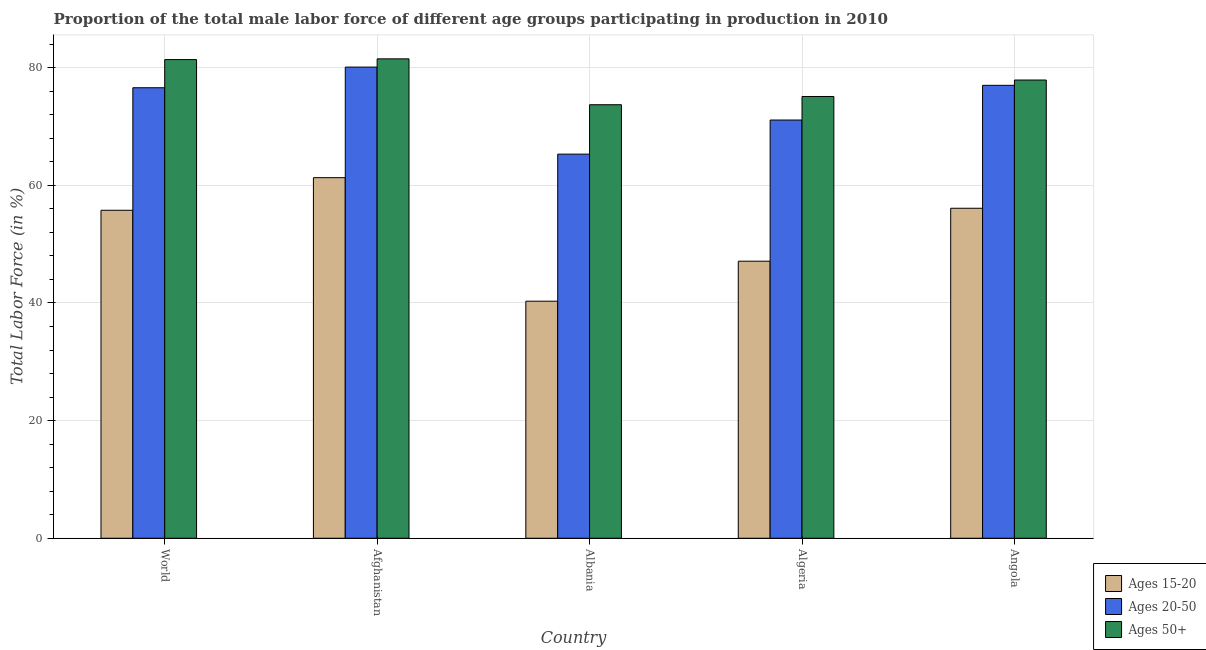How many groups of bars are there?
Offer a terse response. 5. Are the number of bars per tick equal to the number of legend labels?
Keep it short and to the point. Yes. Are the number of bars on each tick of the X-axis equal?
Your answer should be very brief. Yes. How many bars are there on the 2nd tick from the left?
Provide a succinct answer. 3. What is the label of the 2nd group of bars from the left?
Provide a short and direct response. Afghanistan. What is the percentage of male labor force within the age group 20-50 in Algeria?
Offer a very short reply. 71.1. Across all countries, what is the maximum percentage of male labor force within the age group 15-20?
Your answer should be very brief. 61.3. Across all countries, what is the minimum percentage of male labor force above age 50?
Give a very brief answer. 73.7. In which country was the percentage of male labor force above age 50 maximum?
Provide a short and direct response. Afghanistan. In which country was the percentage of male labor force within the age group 15-20 minimum?
Ensure brevity in your answer.  Albania. What is the total percentage of male labor force within the age group 15-20 in the graph?
Offer a terse response. 260.56. What is the difference between the percentage of male labor force above age 50 in Afghanistan and that in Algeria?
Your answer should be compact. 6.4. What is the difference between the percentage of male labor force within the age group 20-50 in Angola and the percentage of male labor force within the age group 15-20 in World?
Make the answer very short. 21.24. What is the average percentage of male labor force within the age group 20-50 per country?
Your answer should be compact. 74.02. What is the difference between the percentage of male labor force within the age group 15-20 and percentage of male labor force within the age group 20-50 in Afghanistan?
Make the answer very short. -18.8. In how many countries, is the percentage of male labor force within the age group 20-50 greater than 8 %?
Provide a succinct answer. 5. What is the ratio of the percentage of male labor force above age 50 in Albania to that in Angola?
Provide a succinct answer. 0.95. Is the difference between the percentage of male labor force within the age group 15-20 in Albania and Algeria greater than the difference between the percentage of male labor force within the age group 20-50 in Albania and Algeria?
Your answer should be compact. No. What is the difference between the highest and the second highest percentage of male labor force within the age group 20-50?
Give a very brief answer. 3.1. In how many countries, is the percentage of male labor force within the age group 15-20 greater than the average percentage of male labor force within the age group 15-20 taken over all countries?
Make the answer very short. 3. Is the sum of the percentage of male labor force within the age group 20-50 in Algeria and Angola greater than the maximum percentage of male labor force above age 50 across all countries?
Your response must be concise. Yes. What does the 3rd bar from the left in Algeria represents?
Provide a short and direct response. Ages 50+. What does the 3rd bar from the right in Algeria represents?
Give a very brief answer. Ages 15-20. Are all the bars in the graph horizontal?
Keep it short and to the point. No. Are the values on the major ticks of Y-axis written in scientific E-notation?
Keep it short and to the point. No. Does the graph contain any zero values?
Offer a terse response. No. Where does the legend appear in the graph?
Give a very brief answer. Bottom right. How many legend labels are there?
Provide a succinct answer. 3. What is the title of the graph?
Your response must be concise. Proportion of the total male labor force of different age groups participating in production in 2010. What is the label or title of the Y-axis?
Give a very brief answer. Total Labor Force (in %). What is the Total Labor Force (in %) in Ages 15-20 in World?
Your answer should be compact. 55.76. What is the Total Labor Force (in %) of Ages 20-50 in World?
Offer a very short reply. 76.59. What is the Total Labor Force (in %) of Ages 50+ in World?
Offer a terse response. 81.37. What is the Total Labor Force (in %) in Ages 15-20 in Afghanistan?
Give a very brief answer. 61.3. What is the Total Labor Force (in %) in Ages 20-50 in Afghanistan?
Give a very brief answer. 80.1. What is the Total Labor Force (in %) of Ages 50+ in Afghanistan?
Keep it short and to the point. 81.5. What is the Total Labor Force (in %) of Ages 15-20 in Albania?
Give a very brief answer. 40.3. What is the Total Labor Force (in %) in Ages 20-50 in Albania?
Your answer should be very brief. 65.3. What is the Total Labor Force (in %) in Ages 50+ in Albania?
Provide a short and direct response. 73.7. What is the Total Labor Force (in %) of Ages 15-20 in Algeria?
Your response must be concise. 47.1. What is the Total Labor Force (in %) of Ages 20-50 in Algeria?
Your response must be concise. 71.1. What is the Total Labor Force (in %) in Ages 50+ in Algeria?
Keep it short and to the point. 75.1. What is the Total Labor Force (in %) of Ages 15-20 in Angola?
Keep it short and to the point. 56.1. What is the Total Labor Force (in %) of Ages 50+ in Angola?
Offer a very short reply. 77.9. Across all countries, what is the maximum Total Labor Force (in %) of Ages 15-20?
Your answer should be very brief. 61.3. Across all countries, what is the maximum Total Labor Force (in %) in Ages 20-50?
Offer a terse response. 80.1. Across all countries, what is the maximum Total Labor Force (in %) in Ages 50+?
Offer a terse response. 81.5. Across all countries, what is the minimum Total Labor Force (in %) in Ages 15-20?
Offer a very short reply. 40.3. Across all countries, what is the minimum Total Labor Force (in %) in Ages 20-50?
Make the answer very short. 65.3. Across all countries, what is the minimum Total Labor Force (in %) of Ages 50+?
Give a very brief answer. 73.7. What is the total Total Labor Force (in %) of Ages 15-20 in the graph?
Keep it short and to the point. 260.56. What is the total Total Labor Force (in %) of Ages 20-50 in the graph?
Give a very brief answer. 370.09. What is the total Total Labor Force (in %) of Ages 50+ in the graph?
Offer a very short reply. 389.57. What is the difference between the Total Labor Force (in %) in Ages 15-20 in World and that in Afghanistan?
Your answer should be very brief. -5.54. What is the difference between the Total Labor Force (in %) in Ages 20-50 in World and that in Afghanistan?
Your response must be concise. -3.51. What is the difference between the Total Labor Force (in %) in Ages 50+ in World and that in Afghanistan?
Your answer should be very brief. -0.13. What is the difference between the Total Labor Force (in %) in Ages 15-20 in World and that in Albania?
Ensure brevity in your answer.  15.46. What is the difference between the Total Labor Force (in %) in Ages 20-50 in World and that in Albania?
Your response must be concise. 11.29. What is the difference between the Total Labor Force (in %) in Ages 50+ in World and that in Albania?
Your answer should be very brief. 7.67. What is the difference between the Total Labor Force (in %) in Ages 15-20 in World and that in Algeria?
Your answer should be very brief. 8.66. What is the difference between the Total Labor Force (in %) of Ages 20-50 in World and that in Algeria?
Offer a very short reply. 5.49. What is the difference between the Total Labor Force (in %) in Ages 50+ in World and that in Algeria?
Provide a succinct answer. 6.27. What is the difference between the Total Labor Force (in %) of Ages 15-20 in World and that in Angola?
Give a very brief answer. -0.34. What is the difference between the Total Labor Force (in %) of Ages 20-50 in World and that in Angola?
Ensure brevity in your answer.  -0.41. What is the difference between the Total Labor Force (in %) of Ages 50+ in World and that in Angola?
Your response must be concise. 3.47. What is the difference between the Total Labor Force (in %) in Ages 15-20 in Afghanistan and that in Albania?
Your answer should be very brief. 21. What is the difference between the Total Labor Force (in %) of Ages 20-50 in Afghanistan and that in Albania?
Your response must be concise. 14.8. What is the difference between the Total Labor Force (in %) of Ages 50+ in Afghanistan and that in Albania?
Your answer should be compact. 7.8. What is the difference between the Total Labor Force (in %) of Ages 15-20 in Afghanistan and that in Algeria?
Offer a terse response. 14.2. What is the difference between the Total Labor Force (in %) of Ages 50+ in Afghanistan and that in Algeria?
Provide a succinct answer. 6.4. What is the difference between the Total Labor Force (in %) of Ages 15-20 in Afghanistan and that in Angola?
Make the answer very short. 5.2. What is the difference between the Total Labor Force (in %) of Ages 15-20 in Albania and that in Algeria?
Provide a short and direct response. -6.8. What is the difference between the Total Labor Force (in %) of Ages 50+ in Albania and that in Algeria?
Provide a succinct answer. -1.4. What is the difference between the Total Labor Force (in %) in Ages 15-20 in Albania and that in Angola?
Ensure brevity in your answer.  -15.8. What is the difference between the Total Labor Force (in %) of Ages 20-50 in Albania and that in Angola?
Your answer should be very brief. -11.7. What is the difference between the Total Labor Force (in %) of Ages 15-20 in Algeria and that in Angola?
Offer a terse response. -9. What is the difference between the Total Labor Force (in %) in Ages 20-50 in Algeria and that in Angola?
Your answer should be very brief. -5.9. What is the difference between the Total Labor Force (in %) of Ages 15-20 in World and the Total Labor Force (in %) of Ages 20-50 in Afghanistan?
Give a very brief answer. -24.34. What is the difference between the Total Labor Force (in %) of Ages 15-20 in World and the Total Labor Force (in %) of Ages 50+ in Afghanistan?
Keep it short and to the point. -25.74. What is the difference between the Total Labor Force (in %) of Ages 20-50 in World and the Total Labor Force (in %) of Ages 50+ in Afghanistan?
Provide a short and direct response. -4.91. What is the difference between the Total Labor Force (in %) in Ages 15-20 in World and the Total Labor Force (in %) in Ages 20-50 in Albania?
Your answer should be compact. -9.54. What is the difference between the Total Labor Force (in %) in Ages 15-20 in World and the Total Labor Force (in %) in Ages 50+ in Albania?
Your response must be concise. -17.94. What is the difference between the Total Labor Force (in %) in Ages 20-50 in World and the Total Labor Force (in %) in Ages 50+ in Albania?
Your response must be concise. 2.89. What is the difference between the Total Labor Force (in %) of Ages 15-20 in World and the Total Labor Force (in %) of Ages 20-50 in Algeria?
Provide a short and direct response. -15.34. What is the difference between the Total Labor Force (in %) in Ages 15-20 in World and the Total Labor Force (in %) in Ages 50+ in Algeria?
Your answer should be very brief. -19.34. What is the difference between the Total Labor Force (in %) in Ages 20-50 in World and the Total Labor Force (in %) in Ages 50+ in Algeria?
Keep it short and to the point. 1.49. What is the difference between the Total Labor Force (in %) in Ages 15-20 in World and the Total Labor Force (in %) in Ages 20-50 in Angola?
Your answer should be compact. -21.24. What is the difference between the Total Labor Force (in %) in Ages 15-20 in World and the Total Labor Force (in %) in Ages 50+ in Angola?
Ensure brevity in your answer.  -22.14. What is the difference between the Total Labor Force (in %) in Ages 20-50 in World and the Total Labor Force (in %) in Ages 50+ in Angola?
Your response must be concise. -1.31. What is the difference between the Total Labor Force (in %) of Ages 15-20 in Afghanistan and the Total Labor Force (in %) of Ages 20-50 in Albania?
Provide a short and direct response. -4. What is the difference between the Total Labor Force (in %) in Ages 15-20 in Afghanistan and the Total Labor Force (in %) in Ages 50+ in Albania?
Offer a terse response. -12.4. What is the difference between the Total Labor Force (in %) of Ages 20-50 in Afghanistan and the Total Labor Force (in %) of Ages 50+ in Albania?
Give a very brief answer. 6.4. What is the difference between the Total Labor Force (in %) in Ages 20-50 in Afghanistan and the Total Labor Force (in %) in Ages 50+ in Algeria?
Offer a very short reply. 5. What is the difference between the Total Labor Force (in %) of Ages 15-20 in Afghanistan and the Total Labor Force (in %) of Ages 20-50 in Angola?
Make the answer very short. -15.7. What is the difference between the Total Labor Force (in %) of Ages 15-20 in Afghanistan and the Total Labor Force (in %) of Ages 50+ in Angola?
Provide a succinct answer. -16.6. What is the difference between the Total Labor Force (in %) in Ages 15-20 in Albania and the Total Labor Force (in %) in Ages 20-50 in Algeria?
Ensure brevity in your answer.  -30.8. What is the difference between the Total Labor Force (in %) of Ages 15-20 in Albania and the Total Labor Force (in %) of Ages 50+ in Algeria?
Keep it short and to the point. -34.8. What is the difference between the Total Labor Force (in %) of Ages 20-50 in Albania and the Total Labor Force (in %) of Ages 50+ in Algeria?
Give a very brief answer. -9.8. What is the difference between the Total Labor Force (in %) in Ages 15-20 in Albania and the Total Labor Force (in %) in Ages 20-50 in Angola?
Your answer should be compact. -36.7. What is the difference between the Total Labor Force (in %) of Ages 15-20 in Albania and the Total Labor Force (in %) of Ages 50+ in Angola?
Offer a very short reply. -37.6. What is the difference between the Total Labor Force (in %) in Ages 15-20 in Algeria and the Total Labor Force (in %) in Ages 20-50 in Angola?
Keep it short and to the point. -29.9. What is the difference between the Total Labor Force (in %) of Ages 15-20 in Algeria and the Total Labor Force (in %) of Ages 50+ in Angola?
Offer a terse response. -30.8. What is the average Total Labor Force (in %) in Ages 15-20 per country?
Your answer should be very brief. 52.11. What is the average Total Labor Force (in %) in Ages 20-50 per country?
Ensure brevity in your answer.  74.02. What is the average Total Labor Force (in %) of Ages 50+ per country?
Provide a short and direct response. 77.91. What is the difference between the Total Labor Force (in %) of Ages 15-20 and Total Labor Force (in %) of Ages 20-50 in World?
Keep it short and to the point. -20.83. What is the difference between the Total Labor Force (in %) of Ages 15-20 and Total Labor Force (in %) of Ages 50+ in World?
Make the answer very short. -25.62. What is the difference between the Total Labor Force (in %) of Ages 20-50 and Total Labor Force (in %) of Ages 50+ in World?
Provide a short and direct response. -4.79. What is the difference between the Total Labor Force (in %) in Ages 15-20 and Total Labor Force (in %) in Ages 20-50 in Afghanistan?
Your response must be concise. -18.8. What is the difference between the Total Labor Force (in %) of Ages 15-20 and Total Labor Force (in %) of Ages 50+ in Afghanistan?
Your answer should be compact. -20.2. What is the difference between the Total Labor Force (in %) of Ages 20-50 and Total Labor Force (in %) of Ages 50+ in Afghanistan?
Provide a succinct answer. -1.4. What is the difference between the Total Labor Force (in %) of Ages 15-20 and Total Labor Force (in %) of Ages 20-50 in Albania?
Keep it short and to the point. -25. What is the difference between the Total Labor Force (in %) of Ages 15-20 and Total Labor Force (in %) of Ages 50+ in Albania?
Your answer should be very brief. -33.4. What is the difference between the Total Labor Force (in %) of Ages 20-50 and Total Labor Force (in %) of Ages 50+ in Albania?
Give a very brief answer. -8.4. What is the difference between the Total Labor Force (in %) of Ages 15-20 and Total Labor Force (in %) of Ages 50+ in Algeria?
Make the answer very short. -28. What is the difference between the Total Labor Force (in %) of Ages 15-20 and Total Labor Force (in %) of Ages 20-50 in Angola?
Provide a succinct answer. -20.9. What is the difference between the Total Labor Force (in %) of Ages 15-20 and Total Labor Force (in %) of Ages 50+ in Angola?
Your response must be concise. -21.8. What is the ratio of the Total Labor Force (in %) of Ages 15-20 in World to that in Afghanistan?
Provide a short and direct response. 0.91. What is the ratio of the Total Labor Force (in %) in Ages 20-50 in World to that in Afghanistan?
Provide a short and direct response. 0.96. What is the ratio of the Total Labor Force (in %) in Ages 50+ in World to that in Afghanistan?
Your response must be concise. 1. What is the ratio of the Total Labor Force (in %) of Ages 15-20 in World to that in Albania?
Your answer should be compact. 1.38. What is the ratio of the Total Labor Force (in %) in Ages 20-50 in World to that in Albania?
Keep it short and to the point. 1.17. What is the ratio of the Total Labor Force (in %) in Ages 50+ in World to that in Albania?
Your response must be concise. 1.1. What is the ratio of the Total Labor Force (in %) in Ages 15-20 in World to that in Algeria?
Offer a terse response. 1.18. What is the ratio of the Total Labor Force (in %) in Ages 20-50 in World to that in Algeria?
Provide a short and direct response. 1.08. What is the ratio of the Total Labor Force (in %) of Ages 50+ in World to that in Algeria?
Provide a short and direct response. 1.08. What is the ratio of the Total Labor Force (in %) of Ages 15-20 in World to that in Angola?
Make the answer very short. 0.99. What is the ratio of the Total Labor Force (in %) in Ages 20-50 in World to that in Angola?
Provide a succinct answer. 0.99. What is the ratio of the Total Labor Force (in %) in Ages 50+ in World to that in Angola?
Provide a succinct answer. 1.04. What is the ratio of the Total Labor Force (in %) of Ages 15-20 in Afghanistan to that in Albania?
Your answer should be very brief. 1.52. What is the ratio of the Total Labor Force (in %) of Ages 20-50 in Afghanistan to that in Albania?
Provide a succinct answer. 1.23. What is the ratio of the Total Labor Force (in %) of Ages 50+ in Afghanistan to that in Albania?
Provide a succinct answer. 1.11. What is the ratio of the Total Labor Force (in %) of Ages 15-20 in Afghanistan to that in Algeria?
Provide a short and direct response. 1.3. What is the ratio of the Total Labor Force (in %) of Ages 20-50 in Afghanistan to that in Algeria?
Make the answer very short. 1.13. What is the ratio of the Total Labor Force (in %) in Ages 50+ in Afghanistan to that in Algeria?
Your answer should be very brief. 1.09. What is the ratio of the Total Labor Force (in %) of Ages 15-20 in Afghanistan to that in Angola?
Your answer should be very brief. 1.09. What is the ratio of the Total Labor Force (in %) of Ages 20-50 in Afghanistan to that in Angola?
Your answer should be compact. 1.04. What is the ratio of the Total Labor Force (in %) in Ages 50+ in Afghanistan to that in Angola?
Your response must be concise. 1.05. What is the ratio of the Total Labor Force (in %) in Ages 15-20 in Albania to that in Algeria?
Offer a terse response. 0.86. What is the ratio of the Total Labor Force (in %) in Ages 20-50 in Albania to that in Algeria?
Ensure brevity in your answer.  0.92. What is the ratio of the Total Labor Force (in %) of Ages 50+ in Albania to that in Algeria?
Ensure brevity in your answer.  0.98. What is the ratio of the Total Labor Force (in %) in Ages 15-20 in Albania to that in Angola?
Offer a very short reply. 0.72. What is the ratio of the Total Labor Force (in %) of Ages 20-50 in Albania to that in Angola?
Your answer should be compact. 0.85. What is the ratio of the Total Labor Force (in %) of Ages 50+ in Albania to that in Angola?
Provide a short and direct response. 0.95. What is the ratio of the Total Labor Force (in %) in Ages 15-20 in Algeria to that in Angola?
Your response must be concise. 0.84. What is the ratio of the Total Labor Force (in %) of Ages 20-50 in Algeria to that in Angola?
Offer a terse response. 0.92. What is the ratio of the Total Labor Force (in %) of Ages 50+ in Algeria to that in Angola?
Provide a succinct answer. 0.96. What is the difference between the highest and the second highest Total Labor Force (in %) of Ages 15-20?
Keep it short and to the point. 5.2. What is the difference between the highest and the second highest Total Labor Force (in %) in Ages 20-50?
Provide a short and direct response. 3.1. What is the difference between the highest and the second highest Total Labor Force (in %) of Ages 50+?
Offer a terse response. 0.13. What is the difference between the highest and the lowest Total Labor Force (in %) of Ages 50+?
Provide a succinct answer. 7.8. 